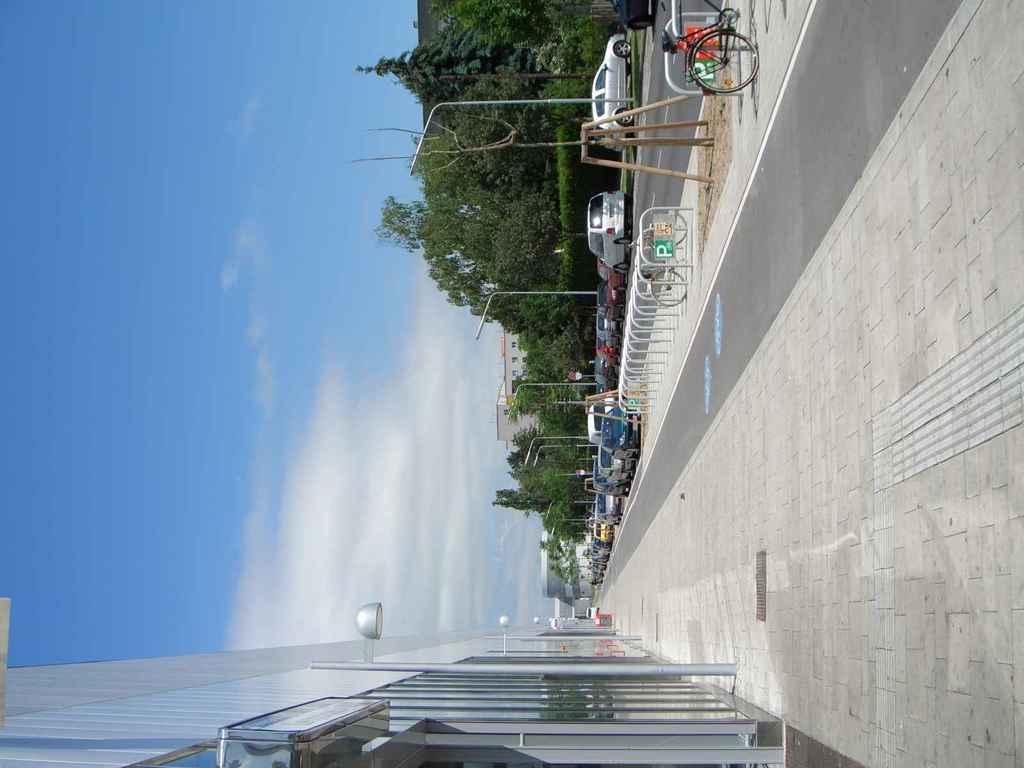In one or two sentences, can you explain what this image depicts? This is a vertical image of a street, there are cars in the middle of the road with trees in the background, in the front there is building with foot path in front of it and above its sky with clouds. 